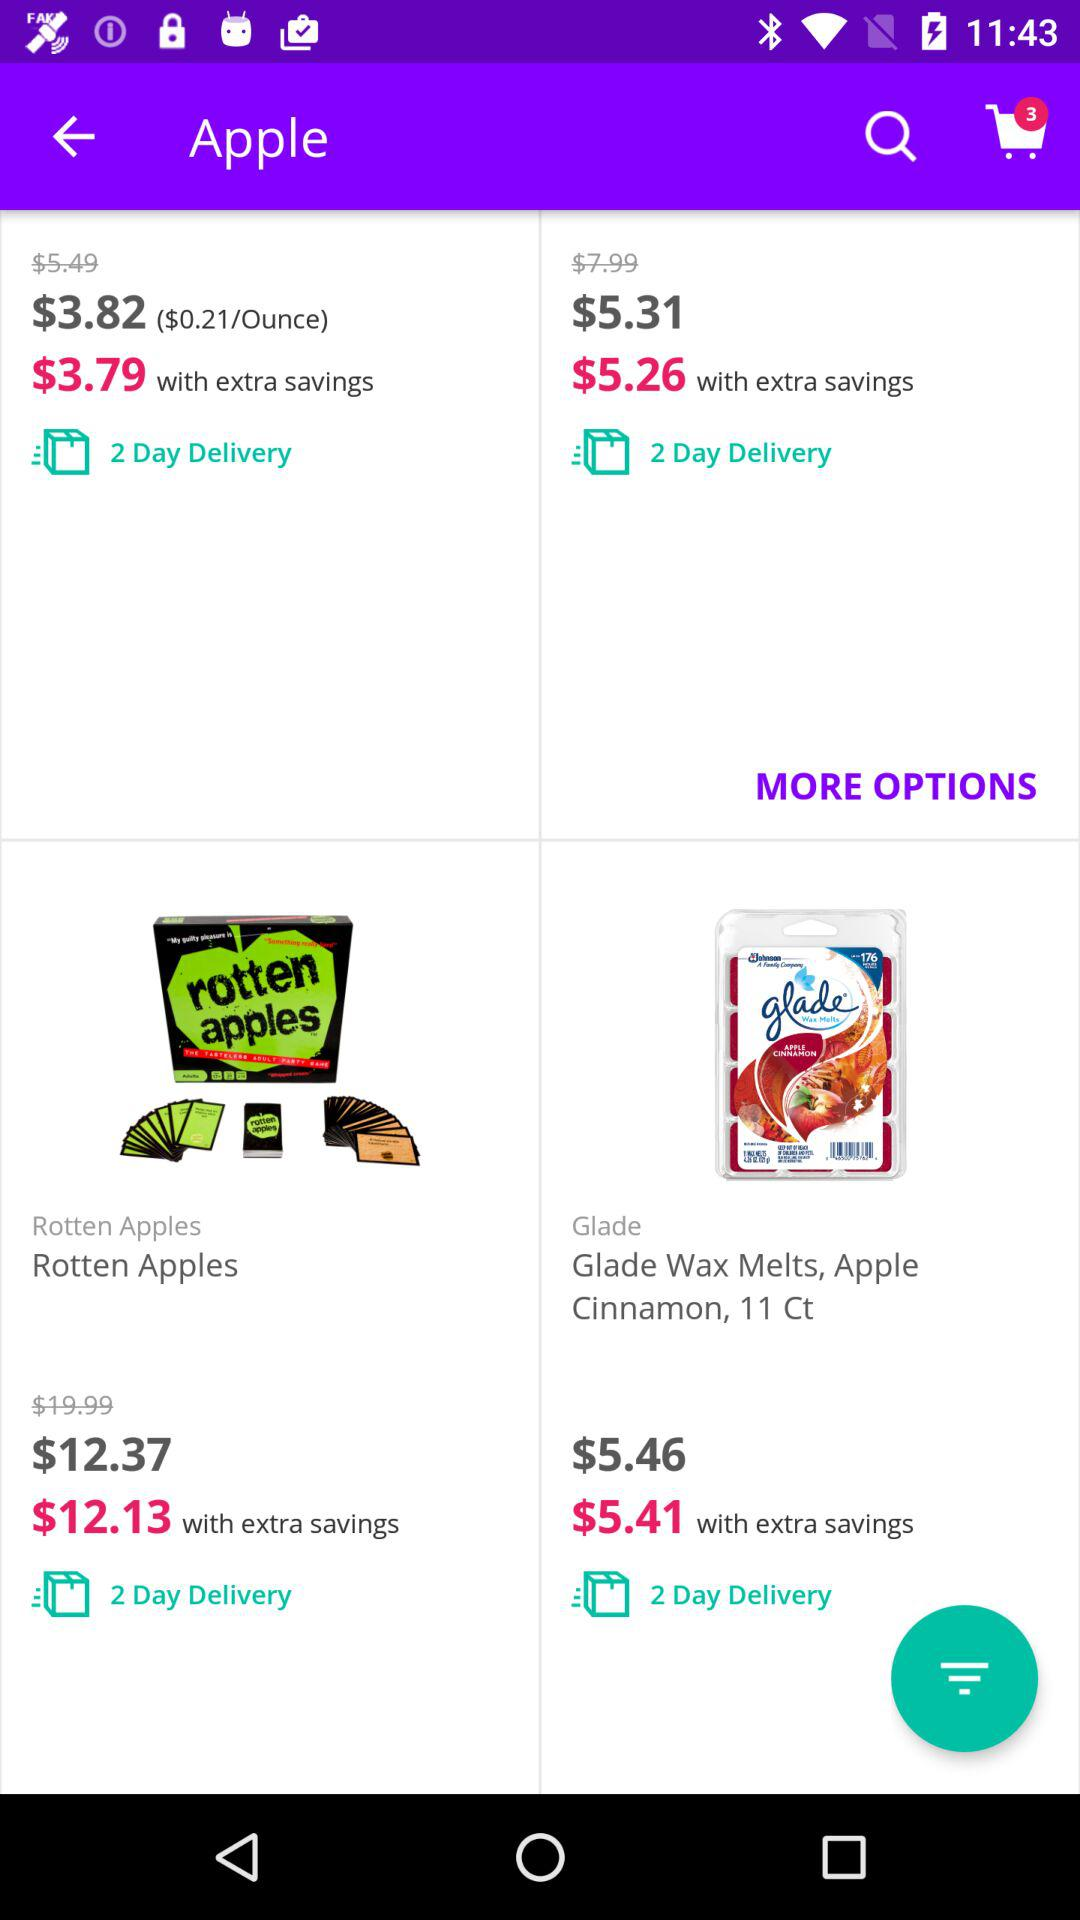What's the price of "Glade Wax Melts, Apple Cinnamon, 11 Ct" with extra savings? The price is $5.41. 